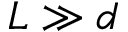<formula> <loc_0><loc_0><loc_500><loc_500>L \gg d</formula> 